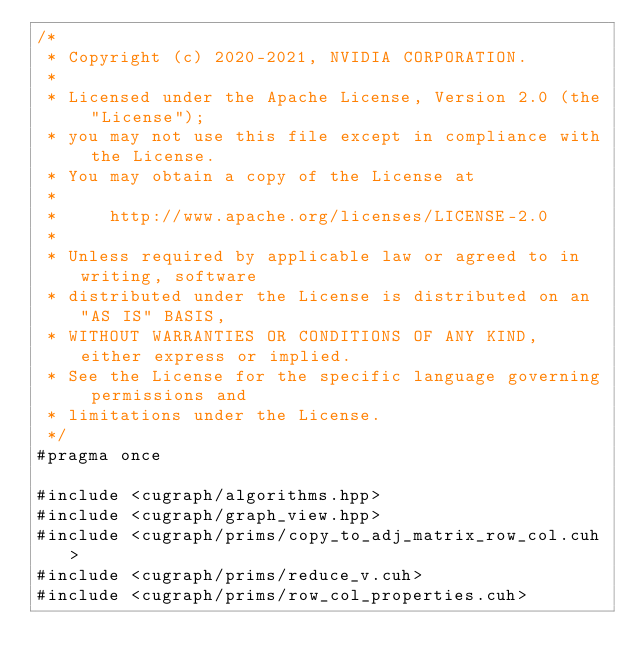<code> <loc_0><loc_0><loc_500><loc_500><_Cuda_>/*
 * Copyright (c) 2020-2021, NVIDIA CORPORATION.
 *
 * Licensed under the Apache License, Version 2.0 (the "License");
 * you may not use this file except in compliance with the License.
 * You may obtain a copy of the License at
 *
 *     http://www.apache.org/licenses/LICENSE-2.0
 *
 * Unless required by applicable law or agreed to in writing, software
 * distributed under the License is distributed on an "AS IS" BASIS,
 * WITHOUT WARRANTIES OR CONDITIONS OF ANY KIND, either express or implied.
 * See the License for the specific language governing permissions and
 * limitations under the License.
 */
#pragma once

#include <cugraph/algorithms.hpp>
#include <cugraph/graph_view.hpp>
#include <cugraph/prims/copy_to_adj_matrix_row_col.cuh>
#include <cugraph/prims/reduce_v.cuh>
#include <cugraph/prims/row_col_properties.cuh></code> 